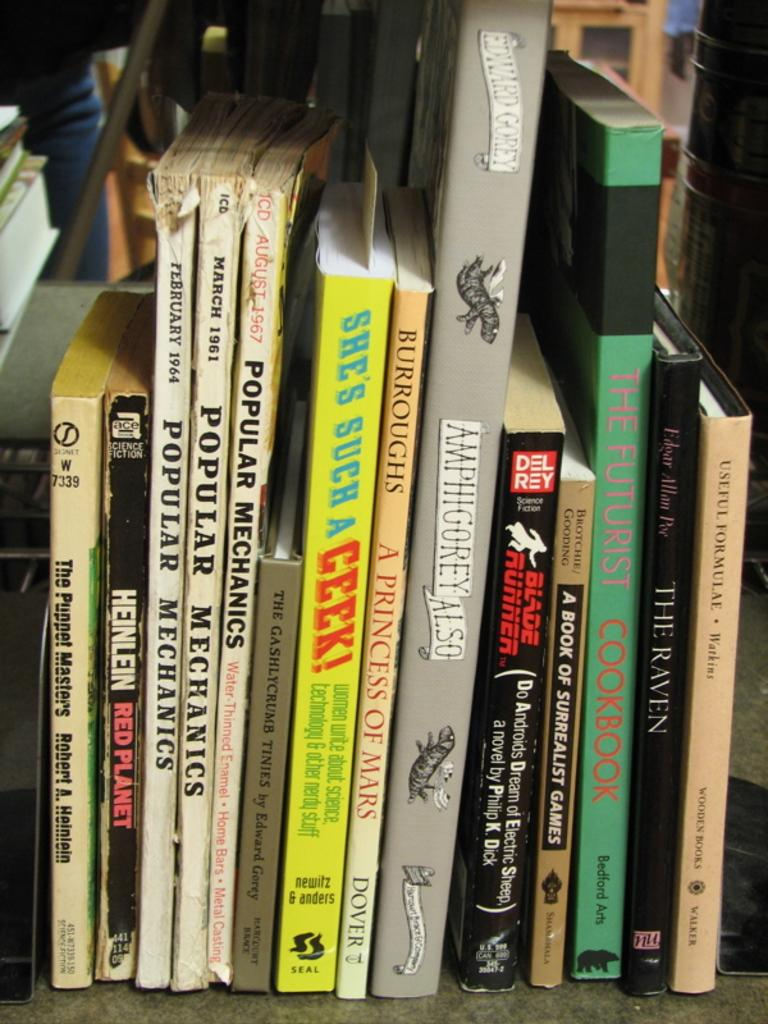<image>
Offer a succinct explanation of the picture presented. books stacked on a shelf including The Futurist Cookbook 